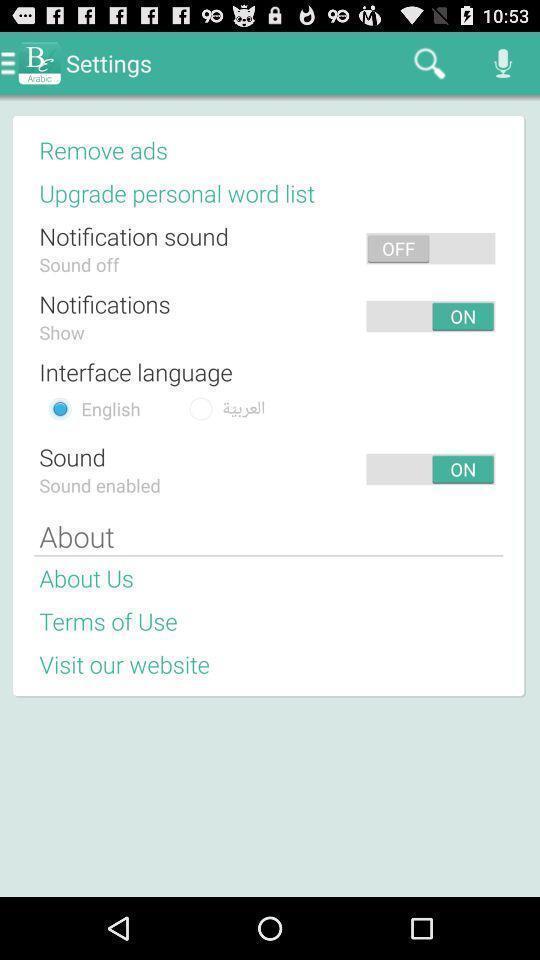What can you discern from this picture? Page displaying various settings. 